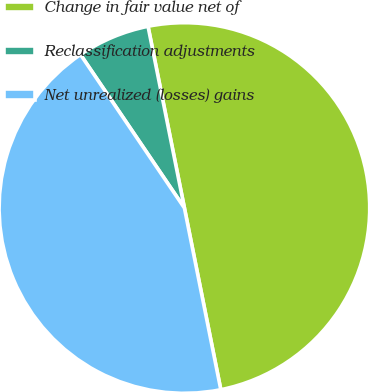Convert chart to OTSL. <chart><loc_0><loc_0><loc_500><loc_500><pie_chart><fcel>Change in fair value net of<fcel>Reclassification adjustments<fcel>Net unrealized (losses) gains<nl><fcel>50.0%<fcel>6.33%<fcel>43.67%<nl></chart> 